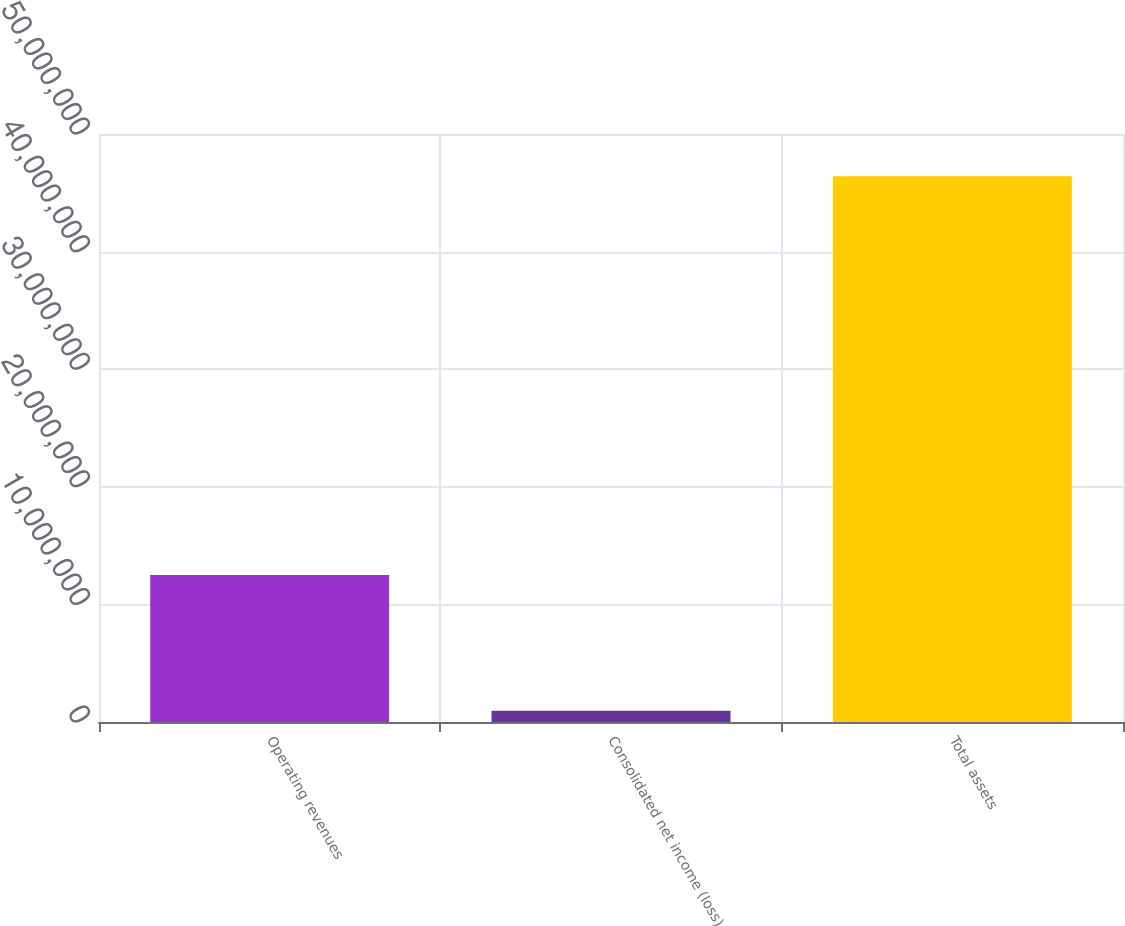<chart> <loc_0><loc_0><loc_500><loc_500><bar_chart><fcel>Operating revenues<fcel>Consolidated net income (loss)<fcel>Total assets<nl><fcel>1.24949e+07<fcel>960257<fcel>4.64145e+07<nl></chart> 